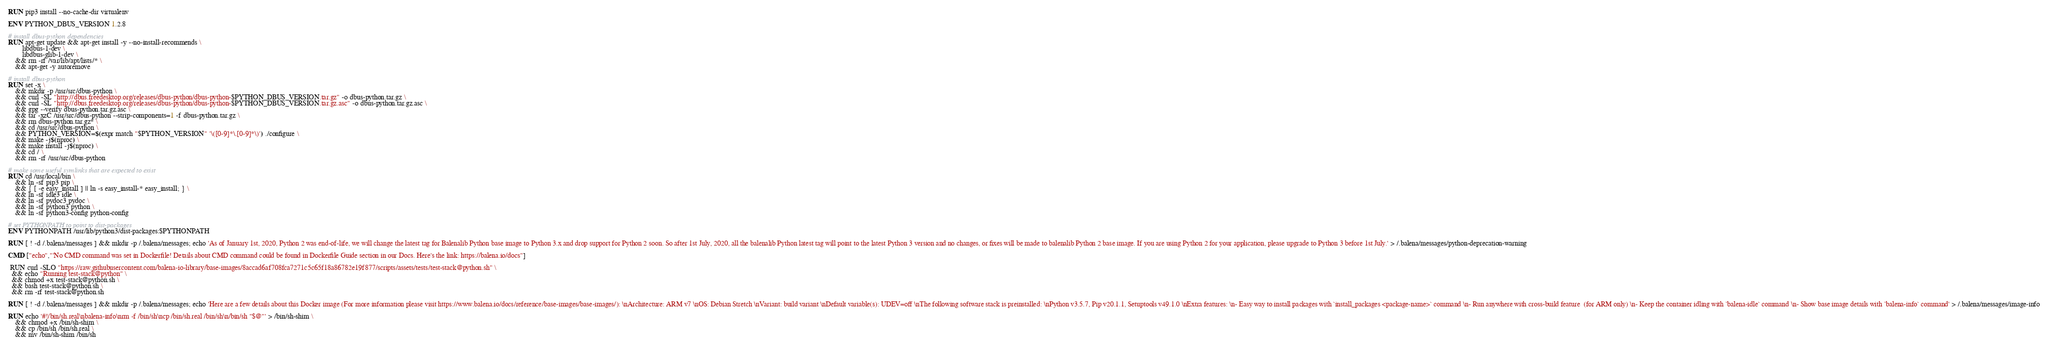<code> <loc_0><loc_0><loc_500><loc_500><_Dockerfile_>RUN pip3 install --no-cache-dir virtualenv

ENV PYTHON_DBUS_VERSION 1.2.8

# install dbus-python dependencies 
RUN apt-get update && apt-get install -y --no-install-recommends \
		libdbus-1-dev \
		libdbus-glib-1-dev \
	&& rm -rf /var/lib/apt/lists/* \
	&& apt-get -y autoremove

# install dbus-python
RUN set -x \
	&& mkdir -p /usr/src/dbus-python \
	&& curl -SL "http://dbus.freedesktop.org/releases/dbus-python/dbus-python-$PYTHON_DBUS_VERSION.tar.gz" -o dbus-python.tar.gz \
	&& curl -SL "http://dbus.freedesktop.org/releases/dbus-python/dbus-python-$PYTHON_DBUS_VERSION.tar.gz.asc" -o dbus-python.tar.gz.asc \
	&& gpg --verify dbus-python.tar.gz.asc \
	&& tar -xzC /usr/src/dbus-python --strip-components=1 -f dbus-python.tar.gz \
	&& rm dbus-python.tar.gz* \
	&& cd /usr/src/dbus-python \
	&& PYTHON_VERSION=$(expr match "$PYTHON_VERSION" '\([0-9]*\.[0-9]*\)') ./configure \
	&& make -j$(nproc) \
	&& make install -j$(nproc) \
	&& cd / \
	&& rm -rf /usr/src/dbus-python

# make some useful symlinks that are expected to exist
RUN cd /usr/local/bin \
	&& ln -sf pip3 pip \
	&& { [ -e easy_install ] || ln -s easy_install-* easy_install; } \
	&& ln -sf idle3 idle \
	&& ln -sf pydoc3 pydoc \
	&& ln -sf python3 python \
	&& ln -sf python3-config python-config

# set PYTHONPATH to point to dist-packages
ENV PYTHONPATH /usr/lib/python3/dist-packages:$PYTHONPATH

RUN [ ! -d /.balena/messages ] && mkdir -p /.balena/messages; echo 'As of January 1st, 2020, Python 2 was end-of-life, we will change the latest tag for Balenalib Python base image to Python 3.x and drop support for Python 2 soon. So after 1st July, 2020, all the balenalib Python latest tag will point to the latest Python 3 version and no changes, or fixes will be made to balenalib Python 2 base image. If you are using Python 2 for your application, please upgrade to Python 3 before 1st July.' > /.balena/messages/python-deprecation-warning

CMD ["echo","'No CMD command was set in Dockerfile! Details about CMD command could be found in Dockerfile Guide section in our Docs. Here's the link: https://balena.io/docs"]

 RUN curl -SLO "https://raw.githubusercontent.com/balena-io-library/base-images/8accad6af708fca7271c5c65f18a86782e19f877/scripts/assets/tests/test-stack@python.sh" \
  && echo "Running test-stack@python" \
  && chmod +x test-stack@python.sh \
  && bash test-stack@python.sh \
  && rm -rf test-stack@python.sh 

RUN [ ! -d /.balena/messages ] && mkdir -p /.balena/messages; echo 'Here are a few details about this Docker image (For more information please visit https://www.balena.io/docs/reference/base-images/base-images/): \nArchitecture: ARM v7 \nOS: Debian Stretch \nVariant: build variant \nDefault variable(s): UDEV=off \nThe following software stack is preinstalled: \nPython v3.5.7, Pip v20.1.1, Setuptools v49.1.0 \nExtra features: \n- Easy way to install packages with `install_packages <package-name>` command \n- Run anywhere with cross-build feature  (for ARM only) \n- Keep the container idling with `balena-idle` command \n- Show base image details with `balena-info` command' > /.balena/messages/image-info

RUN echo '#!/bin/sh.real\nbalena-info\nrm -f /bin/sh\ncp /bin/sh.real /bin/sh\n/bin/sh "$@"' > /bin/sh-shim \
	&& chmod +x /bin/sh-shim \
	&& cp /bin/sh /bin/sh.real \
	&& mv /bin/sh-shim /bin/sh</code> 